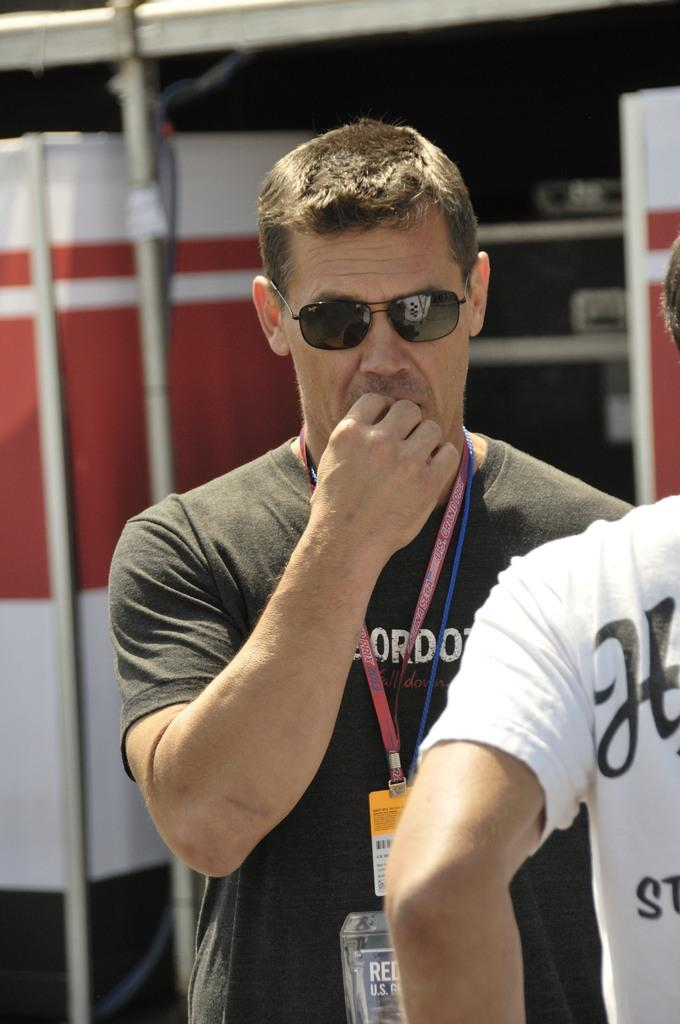<image>
Render a clear and concise summary of the photo. Both of the men have printing on their shirts which is unreadable. 